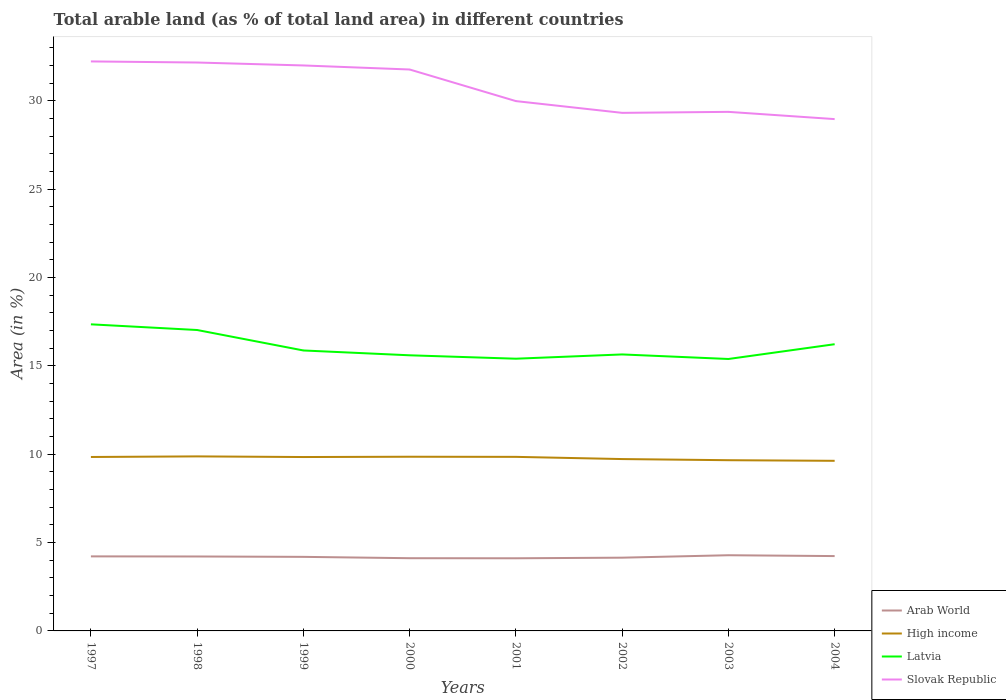How many different coloured lines are there?
Give a very brief answer. 4. Across all years, what is the maximum percentage of arable land in Latvia?
Your response must be concise. 15.39. What is the total percentage of arable land in Arab World in the graph?
Provide a short and direct response. 0.05. What is the difference between the highest and the second highest percentage of arable land in Slovak Republic?
Your answer should be compact. 3.26. What is the difference between the highest and the lowest percentage of arable land in Arab World?
Keep it short and to the point. 5. Is the percentage of arable land in High income strictly greater than the percentage of arable land in Latvia over the years?
Offer a very short reply. Yes. How many lines are there?
Your response must be concise. 4. How many years are there in the graph?
Ensure brevity in your answer.  8. Does the graph contain any zero values?
Your response must be concise. No. Where does the legend appear in the graph?
Give a very brief answer. Bottom right. How many legend labels are there?
Provide a short and direct response. 4. What is the title of the graph?
Provide a succinct answer. Total arable land (as % of total land area) in different countries. What is the label or title of the Y-axis?
Offer a terse response. Area (in %). What is the Area (in %) of Arab World in 1997?
Keep it short and to the point. 4.22. What is the Area (in %) of High income in 1997?
Your response must be concise. 9.84. What is the Area (in %) of Latvia in 1997?
Offer a terse response. 17.35. What is the Area (in %) in Slovak Republic in 1997?
Your answer should be very brief. 32.22. What is the Area (in %) of Arab World in 1998?
Ensure brevity in your answer.  4.21. What is the Area (in %) in High income in 1998?
Offer a terse response. 9.88. What is the Area (in %) of Latvia in 1998?
Make the answer very short. 17.03. What is the Area (in %) of Slovak Republic in 1998?
Your answer should be compact. 32.16. What is the Area (in %) of Arab World in 1999?
Provide a succinct answer. 4.19. What is the Area (in %) of High income in 1999?
Ensure brevity in your answer.  9.84. What is the Area (in %) in Latvia in 1999?
Give a very brief answer. 15.87. What is the Area (in %) in Slovak Republic in 1999?
Provide a succinct answer. 32. What is the Area (in %) of Arab World in 2000?
Provide a short and direct response. 4.11. What is the Area (in %) of High income in 2000?
Provide a short and direct response. 9.86. What is the Area (in %) of Latvia in 2000?
Your response must be concise. 15.6. What is the Area (in %) of Slovak Republic in 2000?
Ensure brevity in your answer.  31.77. What is the Area (in %) in Arab World in 2001?
Keep it short and to the point. 4.11. What is the Area (in %) in High income in 2001?
Provide a short and direct response. 9.85. What is the Area (in %) of Latvia in 2001?
Ensure brevity in your answer.  15.4. What is the Area (in %) in Slovak Republic in 2001?
Your response must be concise. 29.98. What is the Area (in %) in Arab World in 2002?
Your answer should be compact. 4.15. What is the Area (in %) in High income in 2002?
Your answer should be very brief. 9.72. What is the Area (in %) of Latvia in 2002?
Your answer should be compact. 15.64. What is the Area (in %) in Slovak Republic in 2002?
Provide a short and direct response. 29.31. What is the Area (in %) in Arab World in 2003?
Keep it short and to the point. 4.28. What is the Area (in %) in High income in 2003?
Your answer should be compact. 9.66. What is the Area (in %) in Latvia in 2003?
Your response must be concise. 15.39. What is the Area (in %) in Slovak Republic in 2003?
Ensure brevity in your answer.  29.37. What is the Area (in %) of Arab World in 2004?
Ensure brevity in your answer.  4.23. What is the Area (in %) of High income in 2004?
Give a very brief answer. 9.63. What is the Area (in %) in Latvia in 2004?
Give a very brief answer. 16.22. What is the Area (in %) in Slovak Republic in 2004?
Provide a succinct answer. 28.96. Across all years, what is the maximum Area (in %) in Arab World?
Provide a short and direct response. 4.28. Across all years, what is the maximum Area (in %) of High income?
Provide a succinct answer. 9.88. Across all years, what is the maximum Area (in %) in Latvia?
Your response must be concise. 17.35. Across all years, what is the maximum Area (in %) in Slovak Republic?
Provide a short and direct response. 32.22. Across all years, what is the minimum Area (in %) in Arab World?
Your response must be concise. 4.11. Across all years, what is the minimum Area (in %) in High income?
Your response must be concise. 9.63. Across all years, what is the minimum Area (in %) in Latvia?
Offer a very short reply. 15.39. Across all years, what is the minimum Area (in %) in Slovak Republic?
Keep it short and to the point. 28.96. What is the total Area (in %) in Arab World in the graph?
Offer a terse response. 33.51. What is the total Area (in %) of High income in the graph?
Ensure brevity in your answer.  78.27. What is the total Area (in %) of Latvia in the graph?
Keep it short and to the point. 128.5. What is the total Area (in %) in Slovak Republic in the graph?
Make the answer very short. 245.77. What is the difference between the Area (in %) in Arab World in 1997 and that in 1998?
Make the answer very short. 0.01. What is the difference between the Area (in %) in High income in 1997 and that in 1998?
Ensure brevity in your answer.  -0.03. What is the difference between the Area (in %) in Latvia in 1997 and that in 1998?
Give a very brief answer. 0.32. What is the difference between the Area (in %) in Slovak Republic in 1997 and that in 1998?
Offer a very short reply. 0.06. What is the difference between the Area (in %) of Arab World in 1997 and that in 1999?
Offer a terse response. 0.03. What is the difference between the Area (in %) in High income in 1997 and that in 1999?
Keep it short and to the point. 0. What is the difference between the Area (in %) in Latvia in 1997 and that in 1999?
Give a very brief answer. 1.48. What is the difference between the Area (in %) of Slovak Republic in 1997 and that in 1999?
Offer a very short reply. 0.23. What is the difference between the Area (in %) in Arab World in 1997 and that in 2000?
Give a very brief answer. 0.1. What is the difference between the Area (in %) of High income in 1997 and that in 2000?
Make the answer very short. -0.01. What is the difference between the Area (in %) of Latvia in 1997 and that in 2000?
Make the answer very short. 1.75. What is the difference between the Area (in %) of Slovak Republic in 1997 and that in 2000?
Your answer should be compact. 0.46. What is the difference between the Area (in %) in Arab World in 1997 and that in 2001?
Provide a short and direct response. 0.11. What is the difference between the Area (in %) of High income in 1997 and that in 2001?
Provide a succinct answer. -0.01. What is the difference between the Area (in %) in Latvia in 1997 and that in 2001?
Your answer should be very brief. 1.95. What is the difference between the Area (in %) in Slovak Republic in 1997 and that in 2001?
Your response must be concise. 2.25. What is the difference between the Area (in %) of Arab World in 1997 and that in 2002?
Make the answer very short. 0.07. What is the difference between the Area (in %) in High income in 1997 and that in 2002?
Ensure brevity in your answer.  0.12. What is the difference between the Area (in %) of Latvia in 1997 and that in 2002?
Offer a terse response. 1.7. What is the difference between the Area (in %) of Slovak Republic in 1997 and that in 2002?
Offer a very short reply. 2.91. What is the difference between the Area (in %) in Arab World in 1997 and that in 2003?
Your answer should be very brief. -0.06. What is the difference between the Area (in %) in High income in 1997 and that in 2003?
Your response must be concise. 0.18. What is the difference between the Area (in %) in Latvia in 1997 and that in 2003?
Your answer should be compact. 1.96. What is the difference between the Area (in %) of Slovak Republic in 1997 and that in 2003?
Provide a short and direct response. 2.85. What is the difference between the Area (in %) of Arab World in 1997 and that in 2004?
Your response must be concise. -0.02. What is the difference between the Area (in %) in High income in 1997 and that in 2004?
Make the answer very short. 0.22. What is the difference between the Area (in %) of Latvia in 1997 and that in 2004?
Keep it short and to the point. 1.13. What is the difference between the Area (in %) of Slovak Republic in 1997 and that in 2004?
Make the answer very short. 3.26. What is the difference between the Area (in %) in Arab World in 1998 and that in 1999?
Your response must be concise. 0.02. What is the difference between the Area (in %) in High income in 1998 and that in 1999?
Your answer should be very brief. 0.04. What is the difference between the Area (in %) in Latvia in 1998 and that in 1999?
Your answer should be compact. 1.16. What is the difference between the Area (in %) of Slovak Republic in 1998 and that in 1999?
Keep it short and to the point. 0.17. What is the difference between the Area (in %) of Arab World in 1998 and that in 2000?
Offer a very short reply. 0.1. What is the difference between the Area (in %) in High income in 1998 and that in 2000?
Provide a short and direct response. 0.02. What is the difference between the Area (in %) in Latvia in 1998 and that in 2000?
Offer a very short reply. 1.43. What is the difference between the Area (in %) in Slovak Republic in 1998 and that in 2000?
Your answer should be very brief. 0.4. What is the difference between the Area (in %) in Arab World in 1998 and that in 2001?
Provide a succinct answer. 0.1. What is the difference between the Area (in %) of High income in 1998 and that in 2001?
Give a very brief answer. 0.03. What is the difference between the Area (in %) in Latvia in 1998 and that in 2001?
Ensure brevity in your answer.  1.62. What is the difference between the Area (in %) in Slovak Republic in 1998 and that in 2001?
Provide a short and direct response. 2.18. What is the difference between the Area (in %) in Arab World in 1998 and that in 2002?
Provide a succinct answer. 0.07. What is the difference between the Area (in %) of High income in 1998 and that in 2002?
Provide a short and direct response. 0.15. What is the difference between the Area (in %) in Latvia in 1998 and that in 2002?
Offer a very short reply. 1.38. What is the difference between the Area (in %) of Slovak Republic in 1998 and that in 2002?
Offer a terse response. 2.85. What is the difference between the Area (in %) in Arab World in 1998 and that in 2003?
Ensure brevity in your answer.  -0.07. What is the difference between the Area (in %) of High income in 1998 and that in 2003?
Make the answer very short. 0.22. What is the difference between the Area (in %) in Latvia in 1998 and that in 2003?
Provide a succinct answer. 1.64. What is the difference between the Area (in %) in Slovak Republic in 1998 and that in 2003?
Ensure brevity in your answer.  2.79. What is the difference between the Area (in %) of Arab World in 1998 and that in 2004?
Your answer should be very brief. -0.02. What is the difference between the Area (in %) in High income in 1998 and that in 2004?
Your response must be concise. 0.25. What is the difference between the Area (in %) in Latvia in 1998 and that in 2004?
Offer a very short reply. 0.8. What is the difference between the Area (in %) in Slovak Republic in 1998 and that in 2004?
Your answer should be compact. 3.2. What is the difference between the Area (in %) of Arab World in 1999 and that in 2000?
Provide a succinct answer. 0.08. What is the difference between the Area (in %) of High income in 1999 and that in 2000?
Your response must be concise. -0.02. What is the difference between the Area (in %) in Latvia in 1999 and that in 2000?
Give a very brief answer. 0.27. What is the difference between the Area (in %) of Slovak Republic in 1999 and that in 2000?
Make the answer very short. 0.23. What is the difference between the Area (in %) in Arab World in 1999 and that in 2001?
Give a very brief answer. 0.08. What is the difference between the Area (in %) of High income in 1999 and that in 2001?
Provide a succinct answer. -0.01. What is the difference between the Area (in %) in Latvia in 1999 and that in 2001?
Offer a terse response. 0.47. What is the difference between the Area (in %) of Slovak Republic in 1999 and that in 2001?
Offer a very short reply. 2.02. What is the difference between the Area (in %) of Arab World in 1999 and that in 2002?
Keep it short and to the point. 0.05. What is the difference between the Area (in %) of High income in 1999 and that in 2002?
Make the answer very short. 0.11. What is the difference between the Area (in %) of Latvia in 1999 and that in 2002?
Offer a terse response. 0.23. What is the difference between the Area (in %) in Slovak Republic in 1999 and that in 2002?
Offer a terse response. 2.68. What is the difference between the Area (in %) of Arab World in 1999 and that in 2003?
Your answer should be compact. -0.09. What is the difference between the Area (in %) in High income in 1999 and that in 2003?
Your answer should be compact. 0.18. What is the difference between the Area (in %) in Latvia in 1999 and that in 2003?
Provide a succinct answer. 0.48. What is the difference between the Area (in %) of Slovak Republic in 1999 and that in 2003?
Your response must be concise. 2.63. What is the difference between the Area (in %) in Arab World in 1999 and that in 2004?
Your answer should be very brief. -0.04. What is the difference between the Area (in %) of High income in 1999 and that in 2004?
Offer a very short reply. 0.21. What is the difference between the Area (in %) in Latvia in 1999 and that in 2004?
Make the answer very short. -0.35. What is the difference between the Area (in %) of Slovak Republic in 1999 and that in 2004?
Your answer should be very brief. 3.04. What is the difference between the Area (in %) in Arab World in 2000 and that in 2001?
Give a very brief answer. 0. What is the difference between the Area (in %) of High income in 2000 and that in 2001?
Provide a short and direct response. 0.01. What is the difference between the Area (in %) in Latvia in 2000 and that in 2001?
Ensure brevity in your answer.  0.19. What is the difference between the Area (in %) of Slovak Republic in 2000 and that in 2001?
Your answer should be compact. 1.79. What is the difference between the Area (in %) in Arab World in 2000 and that in 2002?
Provide a succinct answer. -0.03. What is the difference between the Area (in %) of High income in 2000 and that in 2002?
Your answer should be very brief. 0.13. What is the difference between the Area (in %) in Latvia in 2000 and that in 2002?
Offer a terse response. -0.05. What is the difference between the Area (in %) in Slovak Republic in 2000 and that in 2002?
Provide a succinct answer. 2.45. What is the difference between the Area (in %) in Arab World in 2000 and that in 2003?
Your response must be concise. -0.17. What is the difference between the Area (in %) of High income in 2000 and that in 2003?
Your answer should be compact. 0.2. What is the difference between the Area (in %) in Latvia in 2000 and that in 2003?
Keep it short and to the point. 0.21. What is the difference between the Area (in %) in Slovak Republic in 2000 and that in 2003?
Give a very brief answer. 2.4. What is the difference between the Area (in %) in Arab World in 2000 and that in 2004?
Your answer should be compact. -0.12. What is the difference between the Area (in %) in High income in 2000 and that in 2004?
Keep it short and to the point. 0.23. What is the difference between the Area (in %) in Latvia in 2000 and that in 2004?
Your response must be concise. -0.63. What is the difference between the Area (in %) of Slovak Republic in 2000 and that in 2004?
Offer a very short reply. 2.81. What is the difference between the Area (in %) in Arab World in 2001 and that in 2002?
Ensure brevity in your answer.  -0.03. What is the difference between the Area (in %) of High income in 2001 and that in 2002?
Provide a short and direct response. 0.12. What is the difference between the Area (in %) of Latvia in 2001 and that in 2002?
Offer a very short reply. -0.24. What is the difference between the Area (in %) of Slovak Republic in 2001 and that in 2002?
Provide a short and direct response. 0.67. What is the difference between the Area (in %) of Arab World in 2001 and that in 2003?
Your answer should be compact. -0.17. What is the difference between the Area (in %) in High income in 2001 and that in 2003?
Your response must be concise. 0.19. What is the difference between the Area (in %) of Latvia in 2001 and that in 2003?
Provide a succinct answer. 0.02. What is the difference between the Area (in %) of Slovak Republic in 2001 and that in 2003?
Make the answer very short. 0.61. What is the difference between the Area (in %) of Arab World in 2001 and that in 2004?
Your answer should be very brief. -0.12. What is the difference between the Area (in %) of High income in 2001 and that in 2004?
Offer a terse response. 0.22. What is the difference between the Area (in %) in Latvia in 2001 and that in 2004?
Your answer should be compact. -0.82. What is the difference between the Area (in %) in Slovak Republic in 2001 and that in 2004?
Make the answer very short. 1.02. What is the difference between the Area (in %) in Arab World in 2002 and that in 2003?
Offer a very short reply. -0.14. What is the difference between the Area (in %) in High income in 2002 and that in 2003?
Your answer should be compact. 0.06. What is the difference between the Area (in %) in Latvia in 2002 and that in 2003?
Your answer should be compact. 0.26. What is the difference between the Area (in %) of Slovak Republic in 2002 and that in 2003?
Give a very brief answer. -0.06. What is the difference between the Area (in %) in Arab World in 2002 and that in 2004?
Your response must be concise. -0.09. What is the difference between the Area (in %) in High income in 2002 and that in 2004?
Your response must be concise. 0.1. What is the difference between the Area (in %) in Latvia in 2002 and that in 2004?
Offer a very short reply. -0.58. What is the difference between the Area (in %) in Slovak Republic in 2002 and that in 2004?
Provide a short and direct response. 0.35. What is the difference between the Area (in %) of Arab World in 2003 and that in 2004?
Offer a very short reply. 0.05. What is the difference between the Area (in %) in High income in 2003 and that in 2004?
Provide a succinct answer. 0.03. What is the difference between the Area (in %) of Latvia in 2003 and that in 2004?
Offer a terse response. -0.84. What is the difference between the Area (in %) in Slovak Republic in 2003 and that in 2004?
Offer a terse response. 0.41. What is the difference between the Area (in %) in Arab World in 1997 and the Area (in %) in High income in 1998?
Your answer should be very brief. -5.66. What is the difference between the Area (in %) in Arab World in 1997 and the Area (in %) in Latvia in 1998?
Your answer should be very brief. -12.81. What is the difference between the Area (in %) of Arab World in 1997 and the Area (in %) of Slovak Republic in 1998?
Give a very brief answer. -27.94. What is the difference between the Area (in %) of High income in 1997 and the Area (in %) of Latvia in 1998?
Your answer should be compact. -7.18. What is the difference between the Area (in %) in High income in 1997 and the Area (in %) in Slovak Republic in 1998?
Give a very brief answer. -22.32. What is the difference between the Area (in %) of Latvia in 1997 and the Area (in %) of Slovak Republic in 1998?
Give a very brief answer. -14.81. What is the difference between the Area (in %) in Arab World in 1997 and the Area (in %) in High income in 1999?
Provide a short and direct response. -5.62. What is the difference between the Area (in %) in Arab World in 1997 and the Area (in %) in Latvia in 1999?
Your answer should be compact. -11.65. What is the difference between the Area (in %) of Arab World in 1997 and the Area (in %) of Slovak Republic in 1999?
Keep it short and to the point. -27.78. What is the difference between the Area (in %) of High income in 1997 and the Area (in %) of Latvia in 1999?
Ensure brevity in your answer.  -6.03. What is the difference between the Area (in %) of High income in 1997 and the Area (in %) of Slovak Republic in 1999?
Provide a short and direct response. -22.15. What is the difference between the Area (in %) of Latvia in 1997 and the Area (in %) of Slovak Republic in 1999?
Keep it short and to the point. -14.65. What is the difference between the Area (in %) in Arab World in 1997 and the Area (in %) in High income in 2000?
Provide a succinct answer. -5.64. What is the difference between the Area (in %) in Arab World in 1997 and the Area (in %) in Latvia in 2000?
Your answer should be very brief. -11.38. What is the difference between the Area (in %) in Arab World in 1997 and the Area (in %) in Slovak Republic in 2000?
Keep it short and to the point. -27.55. What is the difference between the Area (in %) in High income in 1997 and the Area (in %) in Latvia in 2000?
Your answer should be compact. -5.75. What is the difference between the Area (in %) of High income in 1997 and the Area (in %) of Slovak Republic in 2000?
Make the answer very short. -21.93. What is the difference between the Area (in %) in Latvia in 1997 and the Area (in %) in Slovak Republic in 2000?
Make the answer very short. -14.42. What is the difference between the Area (in %) in Arab World in 1997 and the Area (in %) in High income in 2001?
Provide a short and direct response. -5.63. What is the difference between the Area (in %) in Arab World in 1997 and the Area (in %) in Latvia in 2001?
Give a very brief answer. -11.18. What is the difference between the Area (in %) in Arab World in 1997 and the Area (in %) in Slovak Republic in 2001?
Offer a very short reply. -25.76. What is the difference between the Area (in %) of High income in 1997 and the Area (in %) of Latvia in 2001?
Make the answer very short. -5.56. What is the difference between the Area (in %) in High income in 1997 and the Area (in %) in Slovak Republic in 2001?
Provide a short and direct response. -20.14. What is the difference between the Area (in %) in Latvia in 1997 and the Area (in %) in Slovak Republic in 2001?
Provide a succinct answer. -12.63. What is the difference between the Area (in %) in Arab World in 1997 and the Area (in %) in High income in 2002?
Provide a succinct answer. -5.51. What is the difference between the Area (in %) in Arab World in 1997 and the Area (in %) in Latvia in 2002?
Offer a terse response. -11.43. What is the difference between the Area (in %) in Arab World in 1997 and the Area (in %) in Slovak Republic in 2002?
Your answer should be very brief. -25.1. What is the difference between the Area (in %) in High income in 1997 and the Area (in %) in Latvia in 2002?
Make the answer very short. -5.8. What is the difference between the Area (in %) of High income in 1997 and the Area (in %) of Slovak Republic in 2002?
Your answer should be compact. -19.47. What is the difference between the Area (in %) of Latvia in 1997 and the Area (in %) of Slovak Republic in 2002?
Your answer should be very brief. -11.97. What is the difference between the Area (in %) of Arab World in 1997 and the Area (in %) of High income in 2003?
Your answer should be compact. -5.44. What is the difference between the Area (in %) of Arab World in 1997 and the Area (in %) of Latvia in 2003?
Offer a very short reply. -11.17. What is the difference between the Area (in %) in Arab World in 1997 and the Area (in %) in Slovak Republic in 2003?
Provide a short and direct response. -25.15. What is the difference between the Area (in %) in High income in 1997 and the Area (in %) in Latvia in 2003?
Keep it short and to the point. -5.54. What is the difference between the Area (in %) of High income in 1997 and the Area (in %) of Slovak Republic in 2003?
Your answer should be compact. -19.53. What is the difference between the Area (in %) in Latvia in 1997 and the Area (in %) in Slovak Republic in 2003?
Offer a very short reply. -12.02. What is the difference between the Area (in %) in Arab World in 1997 and the Area (in %) in High income in 2004?
Make the answer very short. -5.41. What is the difference between the Area (in %) in Arab World in 1997 and the Area (in %) in Latvia in 2004?
Provide a succinct answer. -12. What is the difference between the Area (in %) in Arab World in 1997 and the Area (in %) in Slovak Republic in 2004?
Your response must be concise. -24.74. What is the difference between the Area (in %) of High income in 1997 and the Area (in %) of Latvia in 2004?
Your response must be concise. -6.38. What is the difference between the Area (in %) of High income in 1997 and the Area (in %) of Slovak Republic in 2004?
Your response must be concise. -19.12. What is the difference between the Area (in %) in Latvia in 1997 and the Area (in %) in Slovak Republic in 2004?
Ensure brevity in your answer.  -11.61. What is the difference between the Area (in %) in Arab World in 1998 and the Area (in %) in High income in 1999?
Give a very brief answer. -5.63. What is the difference between the Area (in %) of Arab World in 1998 and the Area (in %) of Latvia in 1999?
Provide a short and direct response. -11.66. What is the difference between the Area (in %) in Arab World in 1998 and the Area (in %) in Slovak Republic in 1999?
Keep it short and to the point. -27.78. What is the difference between the Area (in %) of High income in 1998 and the Area (in %) of Latvia in 1999?
Ensure brevity in your answer.  -5.99. What is the difference between the Area (in %) in High income in 1998 and the Area (in %) in Slovak Republic in 1999?
Your response must be concise. -22.12. What is the difference between the Area (in %) in Latvia in 1998 and the Area (in %) in Slovak Republic in 1999?
Your response must be concise. -14.97. What is the difference between the Area (in %) in Arab World in 1998 and the Area (in %) in High income in 2000?
Your answer should be compact. -5.64. What is the difference between the Area (in %) of Arab World in 1998 and the Area (in %) of Latvia in 2000?
Your response must be concise. -11.38. What is the difference between the Area (in %) of Arab World in 1998 and the Area (in %) of Slovak Republic in 2000?
Provide a short and direct response. -27.55. What is the difference between the Area (in %) of High income in 1998 and the Area (in %) of Latvia in 2000?
Offer a very short reply. -5.72. What is the difference between the Area (in %) of High income in 1998 and the Area (in %) of Slovak Republic in 2000?
Offer a very short reply. -21.89. What is the difference between the Area (in %) of Latvia in 1998 and the Area (in %) of Slovak Republic in 2000?
Give a very brief answer. -14.74. What is the difference between the Area (in %) of Arab World in 1998 and the Area (in %) of High income in 2001?
Provide a short and direct response. -5.64. What is the difference between the Area (in %) of Arab World in 1998 and the Area (in %) of Latvia in 2001?
Give a very brief answer. -11.19. What is the difference between the Area (in %) in Arab World in 1998 and the Area (in %) in Slovak Republic in 2001?
Offer a very short reply. -25.77. What is the difference between the Area (in %) of High income in 1998 and the Area (in %) of Latvia in 2001?
Give a very brief answer. -5.53. What is the difference between the Area (in %) in High income in 1998 and the Area (in %) in Slovak Republic in 2001?
Your response must be concise. -20.1. What is the difference between the Area (in %) of Latvia in 1998 and the Area (in %) of Slovak Republic in 2001?
Provide a short and direct response. -12.95. What is the difference between the Area (in %) of Arab World in 1998 and the Area (in %) of High income in 2002?
Make the answer very short. -5.51. What is the difference between the Area (in %) in Arab World in 1998 and the Area (in %) in Latvia in 2002?
Ensure brevity in your answer.  -11.43. What is the difference between the Area (in %) of Arab World in 1998 and the Area (in %) of Slovak Republic in 2002?
Provide a short and direct response. -25.1. What is the difference between the Area (in %) of High income in 1998 and the Area (in %) of Latvia in 2002?
Keep it short and to the point. -5.77. What is the difference between the Area (in %) in High income in 1998 and the Area (in %) in Slovak Republic in 2002?
Ensure brevity in your answer.  -19.44. What is the difference between the Area (in %) of Latvia in 1998 and the Area (in %) of Slovak Republic in 2002?
Make the answer very short. -12.29. What is the difference between the Area (in %) of Arab World in 1998 and the Area (in %) of High income in 2003?
Offer a very short reply. -5.45. What is the difference between the Area (in %) in Arab World in 1998 and the Area (in %) in Latvia in 2003?
Provide a short and direct response. -11.17. What is the difference between the Area (in %) in Arab World in 1998 and the Area (in %) in Slovak Republic in 2003?
Your response must be concise. -25.16. What is the difference between the Area (in %) in High income in 1998 and the Area (in %) in Latvia in 2003?
Give a very brief answer. -5.51. What is the difference between the Area (in %) in High income in 1998 and the Area (in %) in Slovak Republic in 2003?
Offer a very short reply. -19.49. What is the difference between the Area (in %) in Latvia in 1998 and the Area (in %) in Slovak Republic in 2003?
Ensure brevity in your answer.  -12.34. What is the difference between the Area (in %) in Arab World in 1998 and the Area (in %) in High income in 2004?
Your answer should be very brief. -5.41. What is the difference between the Area (in %) in Arab World in 1998 and the Area (in %) in Latvia in 2004?
Your answer should be very brief. -12.01. What is the difference between the Area (in %) in Arab World in 1998 and the Area (in %) in Slovak Republic in 2004?
Your answer should be compact. -24.75. What is the difference between the Area (in %) of High income in 1998 and the Area (in %) of Latvia in 2004?
Give a very brief answer. -6.35. What is the difference between the Area (in %) of High income in 1998 and the Area (in %) of Slovak Republic in 2004?
Offer a terse response. -19.08. What is the difference between the Area (in %) of Latvia in 1998 and the Area (in %) of Slovak Republic in 2004?
Your response must be concise. -11.93. What is the difference between the Area (in %) in Arab World in 1999 and the Area (in %) in High income in 2000?
Your answer should be very brief. -5.67. What is the difference between the Area (in %) of Arab World in 1999 and the Area (in %) of Latvia in 2000?
Your response must be concise. -11.41. What is the difference between the Area (in %) of Arab World in 1999 and the Area (in %) of Slovak Republic in 2000?
Ensure brevity in your answer.  -27.58. What is the difference between the Area (in %) of High income in 1999 and the Area (in %) of Latvia in 2000?
Your answer should be very brief. -5.76. What is the difference between the Area (in %) in High income in 1999 and the Area (in %) in Slovak Republic in 2000?
Give a very brief answer. -21.93. What is the difference between the Area (in %) in Latvia in 1999 and the Area (in %) in Slovak Republic in 2000?
Your response must be concise. -15.9. What is the difference between the Area (in %) in Arab World in 1999 and the Area (in %) in High income in 2001?
Offer a terse response. -5.66. What is the difference between the Area (in %) in Arab World in 1999 and the Area (in %) in Latvia in 2001?
Provide a succinct answer. -11.21. What is the difference between the Area (in %) in Arab World in 1999 and the Area (in %) in Slovak Republic in 2001?
Make the answer very short. -25.79. What is the difference between the Area (in %) of High income in 1999 and the Area (in %) of Latvia in 2001?
Offer a terse response. -5.56. What is the difference between the Area (in %) in High income in 1999 and the Area (in %) in Slovak Republic in 2001?
Ensure brevity in your answer.  -20.14. What is the difference between the Area (in %) in Latvia in 1999 and the Area (in %) in Slovak Republic in 2001?
Your answer should be compact. -14.11. What is the difference between the Area (in %) of Arab World in 1999 and the Area (in %) of High income in 2002?
Offer a very short reply. -5.53. What is the difference between the Area (in %) of Arab World in 1999 and the Area (in %) of Latvia in 2002?
Keep it short and to the point. -11.45. What is the difference between the Area (in %) in Arab World in 1999 and the Area (in %) in Slovak Republic in 2002?
Offer a terse response. -25.12. What is the difference between the Area (in %) of High income in 1999 and the Area (in %) of Latvia in 2002?
Make the answer very short. -5.8. What is the difference between the Area (in %) in High income in 1999 and the Area (in %) in Slovak Republic in 2002?
Keep it short and to the point. -19.47. What is the difference between the Area (in %) in Latvia in 1999 and the Area (in %) in Slovak Republic in 2002?
Your answer should be very brief. -13.44. What is the difference between the Area (in %) in Arab World in 1999 and the Area (in %) in High income in 2003?
Make the answer very short. -5.47. What is the difference between the Area (in %) in Arab World in 1999 and the Area (in %) in Latvia in 2003?
Give a very brief answer. -11.2. What is the difference between the Area (in %) in Arab World in 1999 and the Area (in %) in Slovak Republic in 2003?
Offer a terse response. -25.18. What is the difference between the Area (in %) in High income in 1999 and the Area (in %) in Latvia in 2003?
Provide a short and direct response. -5.55. What is the difference between the Area (in %) of High income in 1999 and the Area (in %) of Slovak Republic in 2003?
Your response must be concise. -19.53. What is the difference between the Area (in %) of Latvia in 1999 and the Area (in %) of Slovak Republic in 2003?
Your response must be concise. -13.5. What is the difference between the Area (in %) of Arab World in 1999 and the Area (in %) of High income in 2004?
Give a very brief answer. -5.43. What is the difference between the Area (in %) of Arab World in 1999 and the Area (in %) of Latvia in 2004?
Ensure brevity in your answer.  -12.03. What is the difference between the Area (in %) of Arab World in 1999 and the Area (in %) of Slovak Republic in 2004?
Keep it short and to the point. -24.77. What is the difference between the Area (in %) of High income in 1999 and the Area (in %) of Latvia in 2004?
Offer a terse response. -6.38. What is the difference between the Area (in %) of High income in 1999 and the Area (in %) of Slovak Republic in 2004?
Provide a short and direct response. -19.12. What is the difference between the Area (in %) in Latvia in 1999 and the Area (in %) in Slovak Republic in 2004?
Provide a short and direct response. -13.09. What is the difference between the Area (in %) in Arab World in 2000 and the Area (in %) in High income in 2001?
Offer a very short reply. -5.73. What is the difference between the Area (in %) of Arab World in 2000 and the Area (in %) of Latvia in 2001?
Ensure brevity in your answer.  -11.29. What is the difference between the Area (in %) in Arab World in 2000 and the Area (in %) in Slovak Republic in 2001?
Make the answer very short. -25.86. What is the difference between the Area (in %) in High income in 2000 and the Area (in %) in Latvia in 2001?
Provide a succinct answer. -5.55. What is the difference between the Area (in %) in High income in 2000 and the Area (in %) in Slovak Republic in 2001?
Your response must be concise. -20.12. What is the difference between the Area (in %) of Latvia in 2000 and the Area (in %) of Slovak Republic in 2001?
Offer a terse response. -14.38. What is the difference between the Area (in %) of Arab World in 2000 and the Area (in %) of High income in 2002?
Offer a very short reply. -5.61. What is the difference between the Area (in %) of Arab World in 2000 and the Area (in %) of Latvia in 2002?
Give a very brief answer. -11.53. What is the difference between the Area (in %) of Arab World in 2000 and the Area (in %) of Slovak Republic in 2002?
Offer a very short reply. -25.2. What is the difference between the Area (in %) of High income in 2000 and the Area (in %) of Latvia in 2002?
Your response must be concise. -5.79. What is the difference between the Area (in %) of High income in 2000 and the Area (in %) of Slovak Republic in 2002?
Provide a short and direct response. -19.46. What is the difference between the Area (in %) in Latvia in 2000 and the Area (in %) in Slovak Republic in 2002?
Your answer should be compact. -13.72. What is the difference between the Area (in %) of Arab World in 2000 and the Area (in %) of High income in 2003?
Provide a succinct answer. -5.55. What is the difference between the Area (in %) of Arab World in 2000 and the Area (in %) of Latvia in 2003?
Your answer should be very brief. -11.27. What is the difference between the Area (in %) in Arab World in 2000 and the Area (in %) in Slovak Republic in 2003?
Offer a terse response. -25.26. What is the difference between the Area (in %) of High income in 2000 and the Area (in %) of Latvia in 2003?
Your answer should be very brief. -5.53. What is the difference between the Area (in %) of High income in 2000 and the Area (in %) of Slovak Republic in 2003?
Offer a terse response. -19.51. What is the difference between the Area (in %) of Latvia in 2000 and the Area (in %) of Slovak Republic in 2003?
Make the answer very short. -13.77. What is the difference between the Area (in %) in Arab World in 2000 and the Area (in %) in High income in 2004?
Offer a very short reply. -5.51. What is the difference between the Area (in %) in Arab World in 2000 and the Area (in %) in Latvia in 2004?
Keep it short and to the point. -12.11. What is the difference between the Area (in %) in Arab World in 2000 and the Area (in %) in Slovak Republic in 2004?
Your answer should be compact. -24.85. What is the difference between the Area (in %) in High income in 2000 and the Area (in %) in Latvia in 2004?
Your response must be concise. -6.37. What is the difference between the Area (in %) in High income in 2000 and the Area (in %) in Slovak Republic in 2004?
Provide a succinct answer. -19.1. What is the difference between the Area (in %) in Latvia in 2000 and the Area (in %) in Slovak Republic in 2004?
Your answer should be compact. -13.36. What is the difference between the Area (in %) in Arab World in 2001 and the Area (in %) in High income in 2002?
Provide a short and direct response. -5.61. What is the difference between the Area (in %) in Arab World in 2001 and the Area (in %) in Latvia in 2002?
Your answer should be very brief. -11.53. What is the difference between the Area (in %) in Arab World in 2001 and the Area (in %) in Slovak Republic in 2002?
Give a very brief answer. -25.2. What is the difference between the Area (in %) in High income in 2001 and the Area (in %) in Latvia in 2002?
Make the answer very short. -5.79. What is the difference between the Area (in %) of High income in 2001 and the Area (in %) of Slovak Republic in 2002?
Provide a succinct answer. -19.46. What is the difference between the Area (in %) in Latvia in 2001 and the Area (in %) in Slovak Republic in 2002?
Give a very brief answer. -13.91. What is the difference between the Area (in %) in Arab World in 2001 and the Area (in %) in High income in 2003?
Provide a succinct answer. -5.55. What is the difference between the Area (in %) in Arab World in 2001 and the Area (in %) in Latvia in 2003?
Your response must be concise. -11.28. What is the difference between the Area (in %) in Arab World in 2001 and the Area (in %) in Slovak Republic in 2003?
Your answer should be very brief. -25.26. What is the difference between the Area (in %) in High income in 2001 and the Area (in %) in Latvia in 2003?
Keep it short and to the point. -5.54. What is the difference between the Area (in %) of High income in 2001 and the Area (in %) of Slovak Republic in 2003?
Your answer should be very brief. -19.52. What is the difference between the Area (in %) in Latvia in 2001 and the Area (in %) in Slovak Republic in 2003?
Offer a very short reply. -13.97. What is the difference between the Area (in %) in Arab World in 2001 and the Area (in %) in High income in 2004?
Your answer should be very brief. -5.51. What is the difference between the Area (in %) in Arab World in 2001 and the Area (in %) in Latvia in 2004?
Your answer should be compact. -12.11. What is the difference between the Area (in %) of Arab World in 2001 and the Area (in %) of Slovak Republic in 2004?
Ensure brevity in your answer.  -24.85. What is the difference between the Area (in %) of High income in 2001 and the Area (in %) of Latvia in 2004?
Your response must be concise. -6.37. What is the difference between the Area (in %) of High income in 2001 and the Area (in %) of Slovak Republic in 2004?
Provide a short and direct response. -19.11. What is the difference between the Area (in %) of Latvia in 2001 and the Area (in %) of Slovak Republic in 2004?
Your answer should be compact. -13.56. What is the difference between the Area (in %) in Arab World in 2002 and the Area (in %) in High income in 2003?
Your answer should be very brief. -5.51. What is the difference between the Area (in %) of Arab World in 2002 and the Area (in %) of Latvia in 2003?
Provide a short and direct response. -11.24. What is the difference between the Area (in %) of Arab World in 2002 and the Area (in %) of Slovak Republic in 2003?
Offer a very short reply. -25.23. What is the difference between the Area (in %) of High income in 2002 and the Area (in %) of Latvia in 2003?
Provide a succinct answer. -5.66. What is the difference between the Area (in %) of High income in 2002 and the Area (in %) of Slovak Republic in 2003?
Your answer should be compact. -19.65. What is the difference between the Area (in %) in Latvia in 2002 and the Area (in %) in Slovak Republic in 2003?
Your answer should be compact. -13.73. What is the difference between the Area (in %) in Arab World in 2002 and the Area (in %) in High income in 2004?
Provide a short and direct response. -5.48. What is the difference between the Area (in %) of Arab World in 2002 and the Area (in %) of Latvia in 2004?
Give a very brief answer. -12.08. What is the difference between the Area (in %) of Arab World in 2002 and the Area (in %) of Slovak Republic in 2004?
Offer a very short reply. -24.82. What is the difference between the Area (in %) in High income in 2002 and the Area (in %) in Latvia in 2004?
Provide a short and direct response. -6.5. What is the difference between the Area (in %) of High income in 2002 and the Area (in %) of Slovak Republic in 2004?
Provide a short and direct response. -19.24. What is the difference between the Area (in %) in Latvia in 2002 and the Area (in %) in Slovak Republic in 2004?
Provide a succinct answer. -13.32. What is the difference between the Area (in %) of Arab World in 2003 and the Area (in %) of High income in 2004?
Your response must be concise. -5.34. What is the difference between the Area (in %) in Arab World in 2003 and the Area (in %) in Latvia in 2004?
Your response must be concise. -11.94. What is the difference between the Area (in %) of Arab World in 2003 and the Area (in %) of Slovak Republic in 2004?
Your response must be concise. -24.68. What is the difference between the Area (in %) of High income in 2003 and the Area (in %) of Latvia in 2004?
Provide a short and direct response. -6.56. What is the difference between the Area (in %) in High income in 2003 and the Area (in %) in Slovak Republic in 2004?
Keep it short and to the point. -19.3. What is the difference between the Area (in %) of Latvia in 2003 and the Area (in %) of Slovak Republic in 2004?
Your answer should be very brief. -13.57. What is the average Area (in %) in Arab World per year?
Offer a terse response. 4.19. What is the average Area (in %) of High income per year?
Offer a terse response. 9.78. What is the average Area (in %) of Latvia per year?
Give a very brief answer. 16.06. What is the average Area (in %) in Slovak Republic per year?
Make the answer very short. 30.72. In the year 1997, what is the difference between the Area (in %) of Arab World and Area (in %) of High income?
Provide a short and direct response. -5.62. In the year 1997, what is the difference between the Area (in %) of Arab World and Area (in %) of Latvia?
Provide a short and direct response. -13.13. In the year 1997, what is the difference between the Area (in %) in Arab World and Area (in %) in Slovak Republic?
Offer a terse response. -28.01. In the year 1997, what is the difference between the Area (in %) of High income and Area (in %) of Latvia?
Ensure brevity in your answer.  -7.51. In the year 1997, what is the difference between the Area (in %) in High income and Area (in %) in Slovak Republic?
Your answer should be very brief. -22.38. In the year 1997, what is the difference between the Area (in %) of Latvia and Area (in %) of Slovak Republic?
Your answer should be very brief. -14.88. In the year 1998, what is the difference between the Area (in %) in Arab World and Area (in %) in High income?
Keep it short and to the point. -5.66. In the year 1998, what is the difference between the Area (in %) in Arab World and Area (in %) in Latvia?
Your response must be concise. -12.81. In the year 1998, what is the difference between the Area (in %) in Arab World and Area (in %) in Slovak Republic?
Keep it short and to the point. -27.95. In the year 1998, what is the difference between the Area (in %) of High income and Area (in %) of Latvia?
Offer a terse response. -7.15. In the year 1998, what is the difference between the Area (in %) in High income and Area (in %) in Slovak Republic?
Offer a very short reply. -22.29. In the year 1998, what is the difference between the Area (in %) in Latvia and Area (in %) in Slovak Republic?
Make the answer very short. -15.14. In the year 1999, what is the difference between the Area (in %) in Arab World and Area (in %) in High income?
Ensure brevity in your answer.  -5.65. In the year 1999, what is the difference between the Area (in %) in Arab World and Area (in %) in Latvia?
Provide a succinct answer. -11.68. In the year 1999, what is the difference between the Area (in %) in Arab World and Area (in %) in Slovak Republic?
Ensure brevity in your answer.  -27.81. In the year 1999, what is the difference between the Area (in %) in High income and Area (in %) in Latvia?
Your answer should be very brief. -6.03. In the year 1999, what is the difference between the Area (in %) in High income and Area (in %) in Slovak Republic?
Your answer should be compact. -22.16. In the year 1999, what is the difference between the Area (in %) of Latvia and Area (in %) of Slovak Republic?
Your response must be concise. -16.13. In the year 2000, what is the difference between the Area (in %) in Arab World and Area (in %) in High income?
Offer a terse response. -5.74. In the year 2000, what is the difference between the Area (in %) of Arab World and Area (in %) of Latvia?
Keep it short and to the point. -11.48. In the year 2000, what is the difference between the Area (in %) of Arab World and Area (in %) of Slovak Republic?
Provide a short and direct response. -27.65. In the year 2000, what is the difference between the Area (in %) of High income and Area (in %) of Latvia?
Offer a very short reply. -5.74. In the year 2000, what is the difference between the Area (in %) of High income and Area (in %) of Slovak Republic?
Offer a terse response. -21.91. In the year 2000, what is the difference between the Area (in %) in Latvia and Area (in %) in Slovak Republic?
Ensure brevity in your answer.  -16.17. In the year 2001, what is the difference between the Area (in %) of Arab World and Area (in %) of High income?
Give a very brief answer. -5.74. In the year 2001, what is the difference between the Area (in %) of Arab World and Area (in %) of Latvia?
Offer a very short reply. -11.29. In the year 2001, what is the difference between the Area (in %) in Arab World and Area (in %) in Slovak Republic?
Provide a short and direct response. -25.87. In the year 2001, what is the difference between the Area (in %) in High income and Area (in %) in Latvia?
Your response must be concise. -5.55. In the year 2001, what is the difference between the Area (in %) in High income and Area (in %) in Slovak Republic?
Your answer should be very brief. -20.13. In the year 2001, what is the difference between the Area (in %) in Latvia and Area (in %) in Slovak Republic?
Give a very brief answer. -14.58. In the year 2002, what is the difference between the Area (in %) in Arab World and Area (in %) in High income?
Make the answer very short. -5.58. In the year 2002, what is the difference between the Area (in %) in Arab World and Area (in %) in Latvia?
Make the answer very short. -11.5. In the year 2002, what is the difference between the Area (in %) in Arab World and Area (in %) in Slovak Republic?
Offer a terse response. -25.17. In the year 2002, what is the difference between the Area (in %) in High income and Area (in %) in Latvia?
Provide a succinct answer. -5.92. In the year 2002, what is the difference between the Area (in %) of High income and Area (in %) of Slovak Republic?
Your response must be concise. -19.59. In the year 2002, what is the difference between the Area (in %) in Latvia and Area (in %) in Slovak Republic?
Make the answer very short. -13.67. In the year 2003, what is the difference between the Area (in %) of Arab World and Area (in %) of High income?
Your answer should be compact. -5.38. In the year 2003, what is the difference between the Area (in %) in Arab World and Area (in %) in Latvia?
Make the answer very short. -11.1. In the year 2003, what is the difference between the Area (in %) in Arab World and Area (in %) in Slovak Republic?
Your response must be concise. -25.09. In the year 2003, what is the difference between the Area (in %) of High income and Area (in %) of Latvia?
Keep it short and to the point. -5.73. In the year 2003, what is the difference between the Area (in %) in High income and Area (in %) in Slovak Republic?
Your response must be concise. -19.71. In the year 2003, what is the difference between the Area (in %) in Latvia and Area (in %) in Slovak Republic?
Give a very brief answer. -13.98. In the year 2004, what is the difference between the Area (in %) in Arab World and Area (in %) in High income?
Offer a very short reply. -5.39. In the year 2004, what is the difference between the Area (in %) in Arab World and Area (in %) in Latvia?
Your response must be concise. -11.99. In the year 2004, what is the difference between the Area (in %) of Arab World and Area (in %) of Slovak Republic?
Offer a very short reply. -24.73. In the year 2004, what is the difference between the Area (in %) in High income and Area (in %) in Latvia?
Keep it short and to the point. -6.6. In the year 2004, what is the difference between the Area (in %) of High income and Area (in %) of Slovak Republic?
Keep it short and to the point. -19.34. In the year 2004, what is the difference between the Area (in %) in Latvia and Area (in %) in Slovak Republic?
Provide a short and direct response. -12.74. What is the ratio of the Area (in %) of Arab World in 1997 to that in 1998?
Keep it short and to the point. 1. What is the ratio of the Area (in %) of High income in 1997 to that in 1998?
Your answer should be compact. 1. What is the ratio of the Area (in %) of Latvia in 1997 to that in 1998?
Your answer should be very brief. 1.02. What is the ratio of the Area (in %) in Slovak Republic in 1997 to that in 1998?
Provide a succinct answer. 1. What is the ratio of the Area (in %) of Arab World in 1997 to that in 1999?
Your answer should be compact. 1.01. What is the ratio of the Area (in %) of High income in 1997 to that in 1999?
Give a very brief answer. 1. What is the ratio of the Area (in %) in Latvia in 1997 to that in 1999?
Provide a short and direct response. 1.09. What is the ratio of the Area (in %) of Slovak Republic in 1997 to that in 1999?
Make the answer very short. 1.01. What is the ratio of the Area (in %) of Arab World in 1997 to that in 2000?
Give a very brief answer. 1.03. What is the ratio of the Area (in %) in Latvia in 1997 to that in 2000?
Give a very brief answer. 1.11. What is the ratio of the Area (in %) of Slovak Republic in 1997 to that in 2000?
Your answer should be very brief. 1.01. What is the ratio of the Area (in %) of Arab World in 1997 to that in 2001?
Offer a terse response. 1.03. What is the ratio of the Area (in %) of High income in 1997 to that in 2001?
Your response must be concise. 1. What is the ratio of the Area (in %) of Latvia in 1997 to that in 2001?
Ensure brevity in your answer.  1.13. What is the ratio of the Area (in %) of Slovak Republic in 1997 to that in 2001?
Ensure brevity in your answer.  1.07. What is the ratio of the Area (in %) in Arab World in 1997 to that in 2002?
Keep it short and to the point. 1.02. What is the ratio of the Area (in %) in High income in 1997 to that in 2002?
Provide a short and direct response. 1.01. What is the ratio of the Area (in %) in Latvia in 1997 to that in 2002?
Your answer should be very brief. 1.11. What is the ratio of the Area (in %) of Slovak Republic in 1997 to that in 2002?
Provide a short and direct response. 1.1. What is the ratio of the Area (in %) of Arab World in 1997 to that in 2003?
Give a very brief answer. 0.98. What is the ratio of the Area (in %) in High income in 1997 to that in 2003?
Offer a very short reply. 1.02. What is the ratio of the Area (in %) in Latvia in 1997 to that in 2003?
Your response must be concise. 1.13. What is the ratio of the Area (in %) of Slovak Republic in 1997 to that in 2003?
Ensure brevity in your answer.  1.1. What is the ratio of the Area (in %) in Arab World in 1997 to that in 2004?
Provide a succinct answer. 1. What is the ratio of the Area (in %) of High income in 1997 to that in 2004?
Your answer should be very brief. 1.02. What is the ratio of the Area (in %) of Latvia in 1997 to that in 2004?
Offer a very short reply. 1.07. What is the ratio of the Area (in %) in Slovak Republic in 1997 to that in 2004?
Ensure brevity in your answer.  1.11. What is the ratio of the Area (in %) in Arab World in 1998 to that in 1999?
Offer a terse response. 1.01. What is the ratio of the Area (in %) in Latvia in 1998 to that in 1999?
Offer a very short reply. 1.07. What is the ratio of the Area (in %) in Arab World in 1998 to that in 2000?
Offer a very short reply. 1.02. What is the ratio of the Area (in %) in Latvia in 1998 to that in 2000?
Make the answer very short. 1.09. What is the ratio of the Area (in %) of Slovak Republic in 1998 to that in 2000?
Your answer should be compact. 1.01. What is the ratio of the Area (in %) of Arab World in 1998 to that in 2001?
Offer a very short reply. 1.02. What is the ratio of the Area (in %) in High income in 1998 to that in 2001?
Provide a short and direct response. 1. What is the ratio of the Area (in %) in Latvia in 1998 to that in 2001?
Give a very brief answer. 1.11. What is the ratio of the Area (in %) of Slovak Republic in 1998 to that in 2001?
Provide a short and direct response. 1.07. What is the ratio of the Area (in %) in Arab World in 1998 to that in 2002?
Offer a very short reply. 1.02. What is the ratio of the Area (in %) in High income in 1998 to that in 2002?
Keep it short and to the point. 1.02. What is the ratio of the Area (in %) of Latvia in 1998 to that in 2002?
Provide a short and direct response. 1.09. What is the ratio of the Area (in %) in Slovak Republic in 1998 to that in 2002?
Make the answer very short. 1.1. What is the ratio of the Area (in %) in Arab World in 1998 to that in 2003?
Offer a very short reply. 0.98. What is the ratio of the Area (in %) in High income in 1998 to that in 2003?
Provide a succinct answer. 1.02. What is the ratio of the Area (in %) of Latvia in 1998 to that in 2003?
Offer a very short reply. 1.11. What is the ratio of the Area (in %) of Slovak Republic in 1998 to that in 2003?
Offer a very short reply. 1.1. What is the ratio of the Area (in %) in High income in 1998 to that in 2004?
Your answer should be very brief. 1.03. What is the ratio of the Area (in %) of Latvia in 1998 to that in 2004?
Keep it short and to the point. 1.05. What is the ratio of the Area (in %) in Slovak Republic in 1998 to that in 2004?
Provide a short and direct response. 1.11. What is the ratio of the Area (in %) of Arab World in 1999 to that in 2000?
Give a very brief answer. 1.02. What is the ratio of the Area (in %) of Latvia in 1999 to that in 2000?
Provide a short and direct response. 1.02. What is the ratio of the Area (in %) of Slovak Republic in 1999 to that in 2000?
Give a very brief answer. 1.01. What is the ratio of the Area (in %) in Arab World in 1999 to that in 2001?
Your answer should be very brief. 1.02. What is the ratio of the Area (in %) in High income in 1999 to that in 2001?
Your answer should be compact. 1. What is the ratio of the Area (in %) in Latvia in 1999 to that in 2001?
Ensure brevity in your answer.  1.03. What is the ratio of the Area (in %) of Slovak Republic in 1999 to that in 2001?
Make the answer very short. 1.07. What is the ratio of the Area (in %) of Arab World in 1999 to that in 2002?
Provide a short and direct response. 1.01. What is the ratio of the Area (in %) of High income in 1999 to that in 2002?
Offer a terse response. 1.01. What is the ratio of the Area (in %) in Latvia in 1999 to that in 2002?
Your answer should be compact. 1.01. What is the ratio of the Area (in %) of Slovak Republic in 1999 to that in 2002?
Offer a terse response. 1.09. What is the ratio of the Area (in %) of Arab World in 1999 to that in 2003?
Your answer should be compact. 0.98. What is the ratio of the Area (in %) of High income in 1999 to that in 2003?
Your answer should be very brief. 1.02. What is the ratio of the Area (in %) of Latvia in 1999 to that in 2003?
Your answer should be compact. 1.03. What is the ratio of the Area (in %) in Slovak Republic in 1999 to that in 2003?
Provide a succinct answer. 1.09. What is the ratio of the Area (in %) in Arab World in 1999 to that in 2004?
Give a very brief answer. 0.99. What is the ratio of the Area (in %) in High income in 1999 to that in 2004?
Your answer should be very brief. 1.02. What is the ratio of the Area (in %) of Latvia in 1999 to that in 2004?
Provide a succinct answer. 0.98. What is the ratio of the Area (in %) of Slovak Republic in 1999 to that in 2004?
Provide a succinct answer. 1.1. What is the ratio of the Area (in %) in Arab World in 2000 to that in 2001?
Your answer should be compact. 1. What is the ratio of the Area (in %) in High income in 2000 to that in 2001?
Give a very brief answer. 1. What is the ratio of the Area (in %) in Latvia in 2000 to that in 2001?
Your response must be concise. 1.01. What is the ratio of the Area (in %) of Slovak Republic in 2000 to that in 2001?
Your answer should be very brief. 1.06. What is the ratio of the Area (in %) in Arab World in 2000 to that in 2002?
Keep it short and to the point. 0.99. What is the ratio of the Area (in %) in High income in 2000 to that in 2002?
Ensure brevity in your answer.  1.01. What is the ratio of the Area (in %) of Latvia in 2000 to that in 2002?
Your answer should be compact. 1. What is the ratio of the Area (in %) in Slovak Republic in 2000 to that in 2002?
Your answer should be compact. 1.08. What is the ratio of the Area (in %) in Arab World in 2000 to that in 2003?
Give a very brief answer. 0.96. What is the ratio of the Area (in %) of High income in 2000 to that in 2003?
Offer a terse response. 1.02. What is the ratio of the Area (in %) in Latvia in 2000 to that in 2003?
Ensure brevity in your answer.  1.01. What is the ratio of the Area (in %) in Slovak Republic in 2000 to that in 2003?
Provide a short and direct response. 1.08. What is the ratio of the Area (in %) of Arab World in 2000 to that in 2004?
Keep it short and to the point. 0.97. What is the ratio of the Area (in %) of High income in 2000 to that in 2004?
Your answer should be very brief. 1.02. What is the ratio of the Area (in %) of Latvia in 2000 to that in 2004?
Offer a very short reply. 0.96. What is the ratio of the Area (in %) of Slovak Republic in 2000 to that in 2004?
Provide a short and direct response. 1.1. What is the ratio of the Area (in %) of High income in 2001 to that in 2002?
Give a very brief answer. 1.01. What is the ratio of the Area (in %) of Latvia in 2001 to that in 2002?
Keep it short and to the point. 0.98. What is the ratio of the Area (in %) in Slovak Republic in 2001 to that in 2002?
Your answer should be very brief. 1.02. What is the ratio of the Area (in %) in Arab World in 2001 to that in 2003?
Make the answer very short. 0.96. What is the ratio of the Area (in %) of High income in 2001 to that in 2003?
Your answer should be compact. 1.02. What is the ratio of the Area (in %) in Latvia in 2001 to that in 2003?
Your answer should be very brief. 1. What is the ratio of the Area (in %) in Slovak Republic in 2001 to that in 2003?
Provide a succinct answer. 1.02. What is the ratio of the Area (in %) in Arab World in 2001 to that in 2004?
Make the answer very short. 0.97. What is the ratio of the Area (in %) of High income in 2001 to that in 2004?
Provide a short and direct response. 1.02. What is the ratio of the Area (in %) of Latvia in 2001 to that in 2004?
Keep it short and to the point. 0.95. What is the ratio of the Area (in %) in Slovak Republic in 2001 to that in 2004?
Ensure brevity in your answer.  1.04. What is the ratio of the Area (in %) of Arab World in 2002 to that in 2003?
Your answer should be very brief. 0.97. What is the ratio of the Area (in %) in High income in 2002 to that in 2003?
Make the answer very short. 1.01. What is the ratio of the Area (in %) of Latvia in 2002 to that in 2003?
Ensure brevity in your answer.  1.02. What is the ratio of the Area (in %) in Arab World in 2002 to that in 2004?
Ensure brevity in your answer.  0.98. What is the ratio of the Area (in %) in High income in 2002 to that in 2004?
Keep it short and to the point. 1.01. What is the ratio of the Area (in %) of Slovak Republic in 2002 to that in 2004?
Offer a very short reply. 1.01. What is the ratio of the Area (in %) of Arab World in 2003 to that in 2004?
Ensure brevity in your answer.  1.01. What is the ratio of the Area (in %) in Latvia in 2003 to that in 2004?
Offer a terse response. 0.95. What is the ratio of the Area (in %) in Slovak Republic in 2003 to that in 2004?
Provide a succinct answer. 1.01. What is the difference between the highest and the second highest Area (in %) of Arab World?
Ensure brevity in your answer.  0.05. What is the difference between the highest and the second highest Area (in %) of High income?
Your answer should be very brief. 0.02. What is the difference between the highest and the second highest Area (in %) in Latvia?
Your answer should be very brief. 0.32. What is the difference between the highest and the second highest Area (in %) of Slovak Republic?
Provide a succinct answer. 0.06. What is the difference between the highest and the lowest Area (in %) in Arab World?
Offer a terse response. 0.17. What is the difference between the highest and the lowest Area (in %) in High income?
Make the answer very short. 0.25. What is the difference between the highest and the lowest Area (in %) of Latvia?
Your answer should be compact. 1.96. What is the difference between the highest and the lowest Area (in %) of Slovak Republic?
Provide a succinct answer. 3.26. 